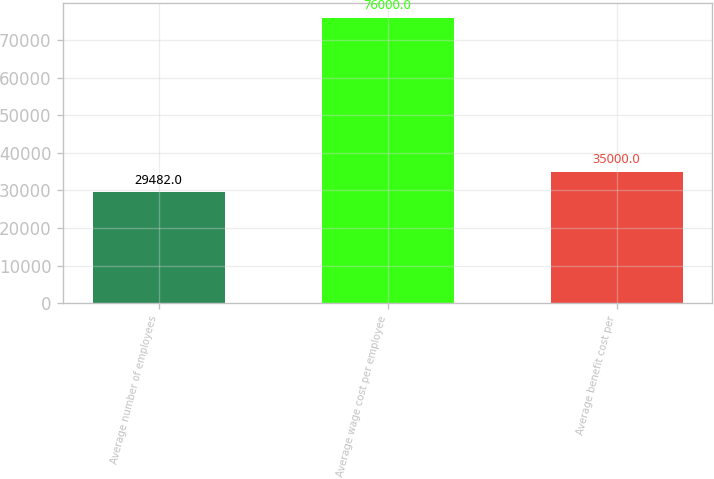<chart> <loc_0><loc_0><loc_500><loc_500><bar_chart><fcel>Average number of employees<fcel>Average wage cost per employee<fcel>Average benefit cost per<nl><fcel>29482<fcel>76000<fcel>35000<nl></chart> 